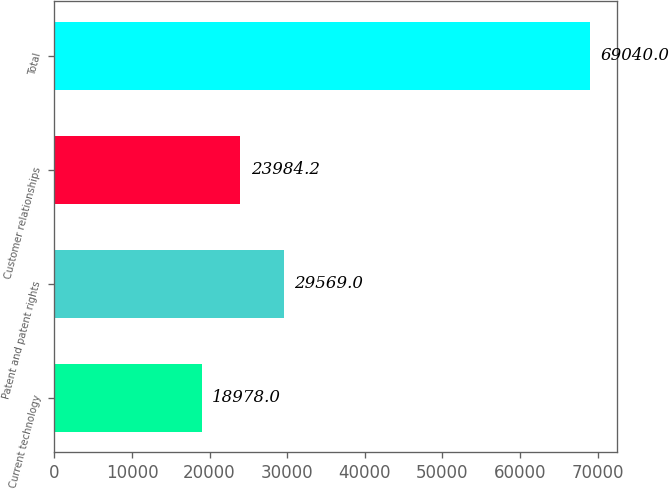Convert chart. <chart><loc_0><loc_0><loc_500><loc_500><bar_chart><fcel>Current technology<fcel>Patent and patent rights<fcel>Customer relationships<fcel>Total<nl><fcel>18978<fcel>29569<fcel>23984.2<fcel>69040<nl></chart> 